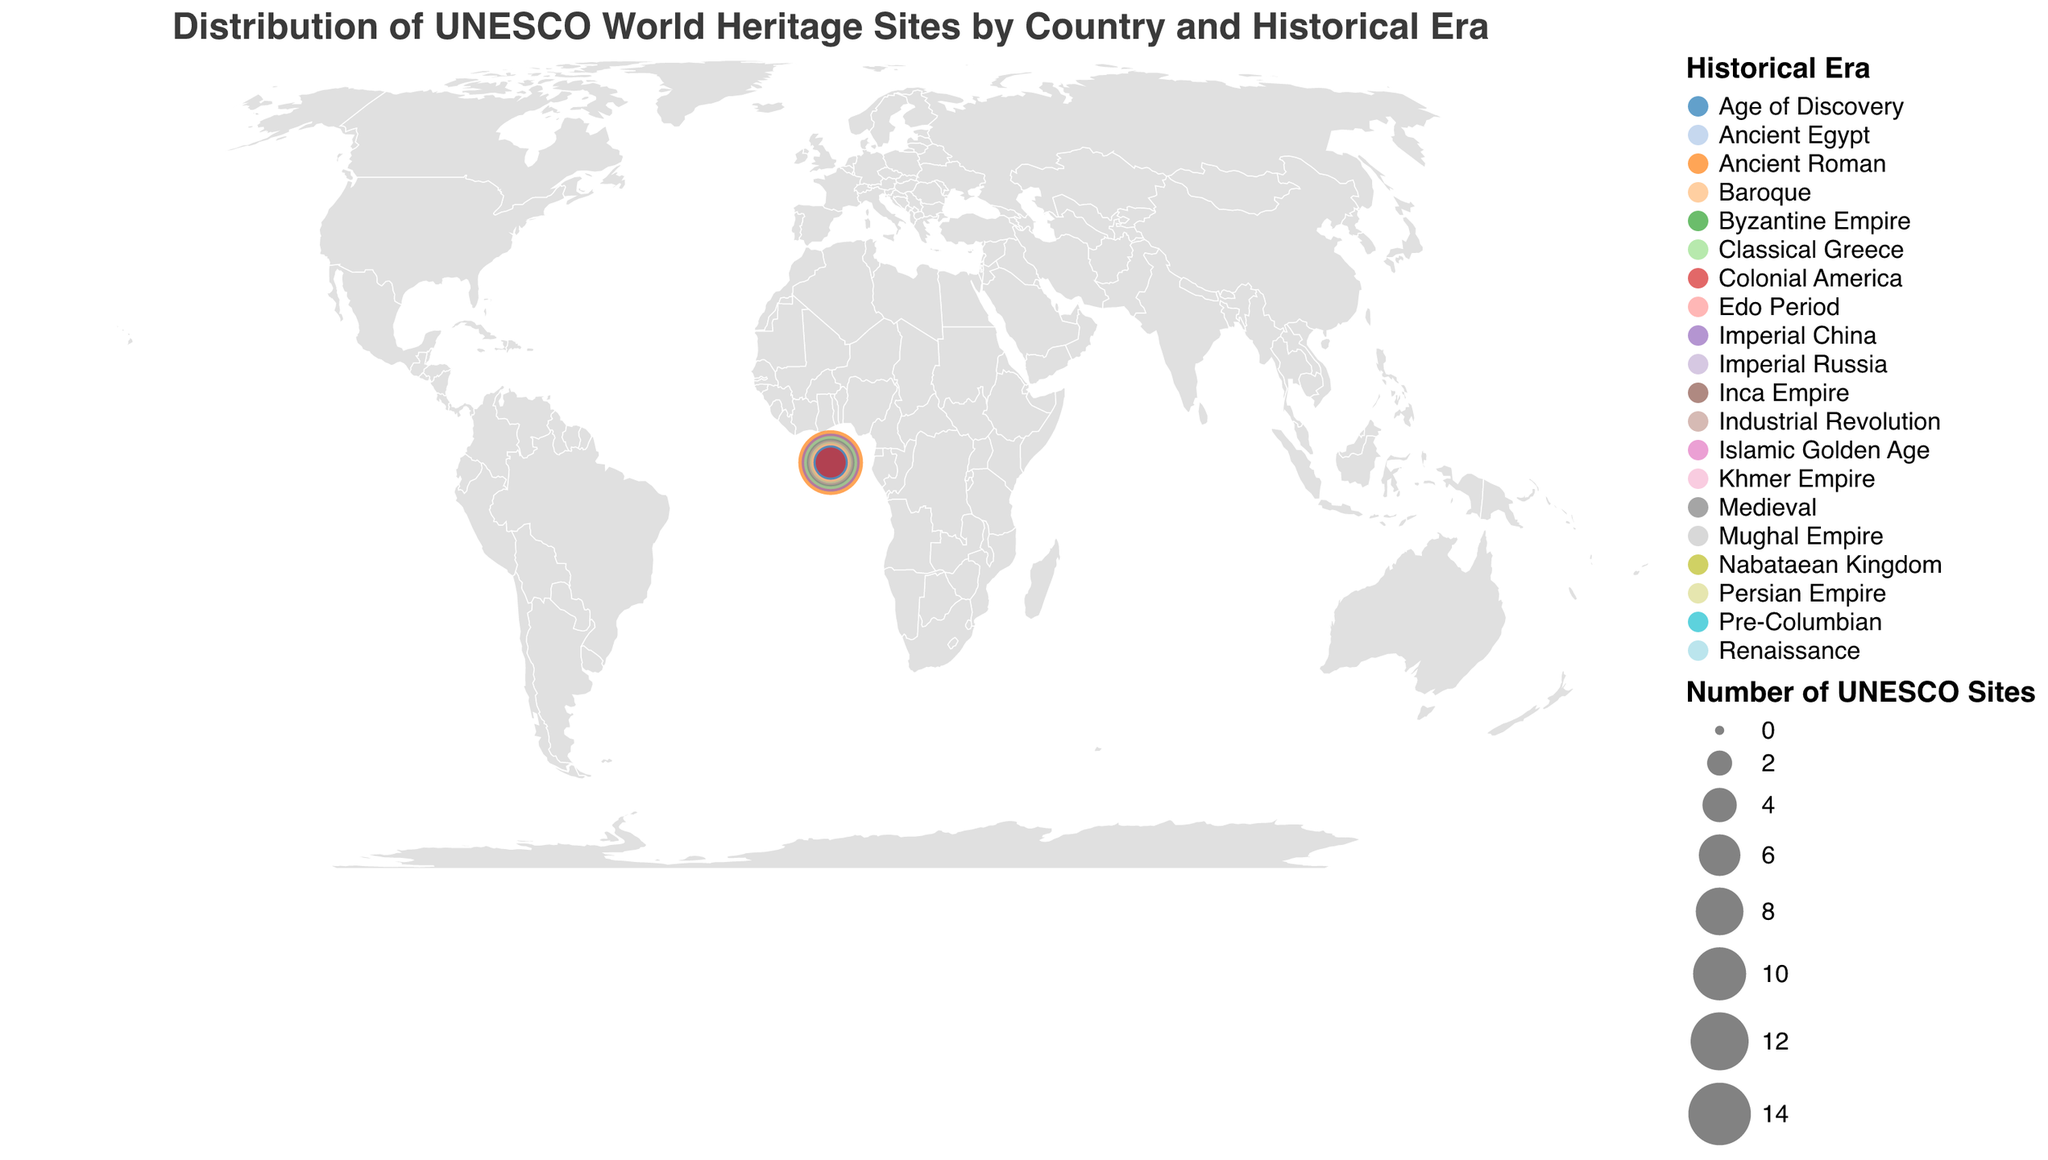How many UNESCO World Heritage Sites are there in Italy? The figure shows a circle for each country, with the size of the circle representing the number of sites. Italy has a circle labeled "15".
Answer: 15 Which country has the highest number of UNESCO World Heritage Sites? Observing the size of circles and labels, Italy has the largest circle with 15 sites.
Answer: Italy Which country has the most sites from the Ancient Roman era? Italy is the only country labeled with the Ancient Roman era and has 15 sites.
Answer: Italy Compare the number of sites in France and Spain. Which has more? France shows 8 sites, while Spain shows 6 sites. Therefore, France has more sites than Spain.
Answer: France What is the combined number of UNESCO World Heritage Sites in Egypt and Greece? Egypt has 7 sites and Greece has 10 sites. 7 + 10 = 17.
Answer: 17 Which historical era has the highest representation, and from which country? The Ancient Roman era in Italy has the highest number of sites, which is 15.
Answer: Ancient Roman, Italy Identify the country with the least number of UNESCO World Heritage Sites and state the era. Jordan has the smallest circle labeled with 2 sites from the Nabataean Kingdom era.
Answer: Jordan, Nabataean Kingdom How many countries have sites from the medieval era? The figure shows France with sites from the Medieval era. Only France is listed under this era.
Answer: 1 Find the average number of UNESCO World Heritage Sites listed for countries in Asia (China, India, Japan, Cambodia, Iran). Sites per country: China 12, India 5, Japan 5, Cambodia 3, Iran 3. Average = (12 + 5 + 5 + 3 + 3) / 5 = 28 / 5 = 5.6.
Answer: 5.6 How many particles represent sites from historical eras that span beyond Europe? Italy, Greece, France, Spain, Germany, Russia, Portugal, and the United Kingdom are in Europe. Non-European: China 12, Egypt 7, Turkey 4, India 5, Mexico 6, Peru 4, Japan 5, Cambodia 3, Jordan 2, Iran 3, Morocco 3, USA 3. Therefore, number of non-European sites: 12 + 7 + 4 + 5 + 6 + 4 + 5 + 3 + 2 + 3 + 3 + 3 = 57 sites.
Answer: 57 